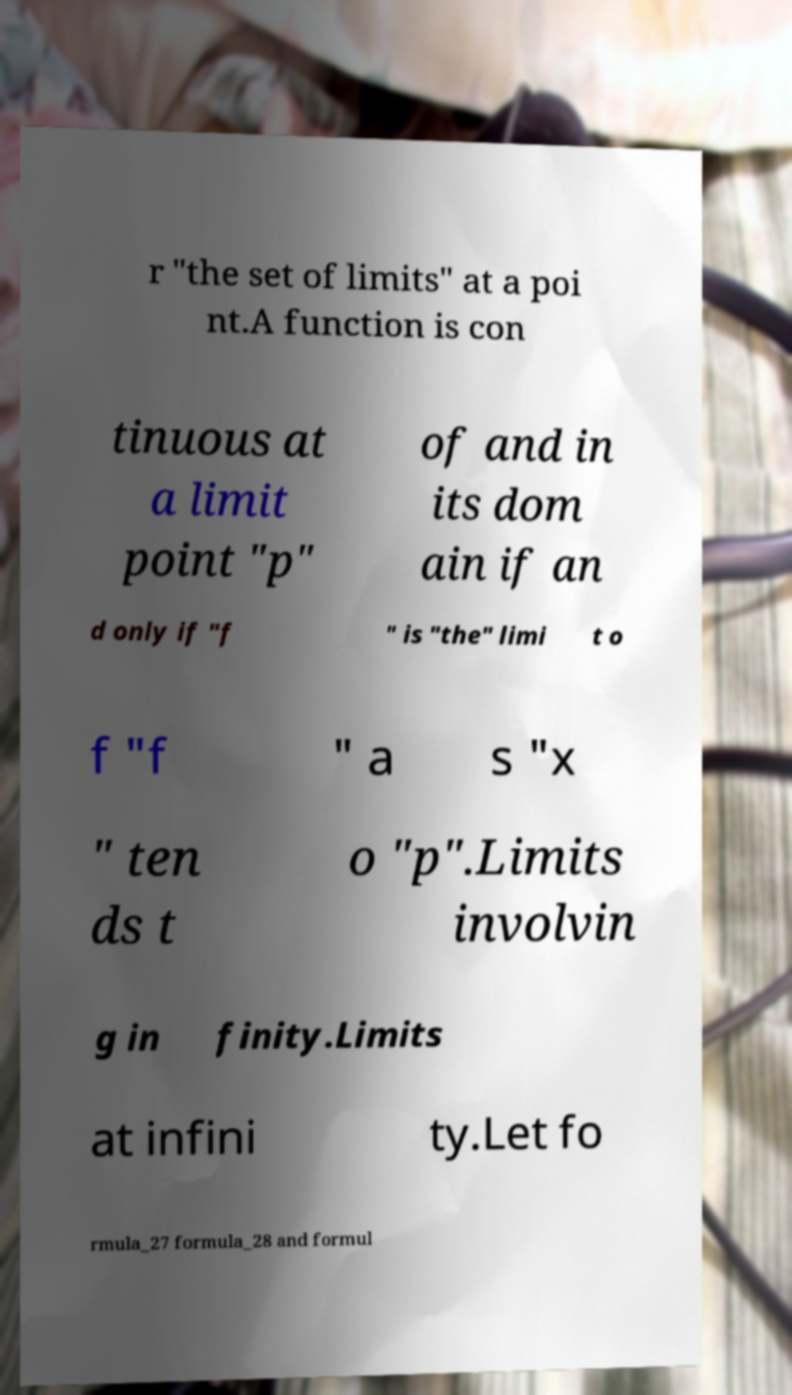Can you read and provide the text displayed in the image?This photo seems to have some interesting text. Can you extract and type it out for me? r "the set of limits" at a poi nt.A function is con tinuous at a limit point "p" of and in its dom ain if an d only if "f " is "the" limi t o f "f " a s "x " ten ds t o "p".Limits involvin g in finity.Limits at infini ty.Let fo rmula_27 formula_28 and formul 